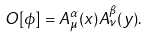Convert formula to latex. <formula><loc_0><loc_0><loc_500><loc_500>O [ \phi ] = A ^ { \alpha } _ { \mu } ( x ) A ^ { \beta } _ { \nu } ( y ) .</formula> 